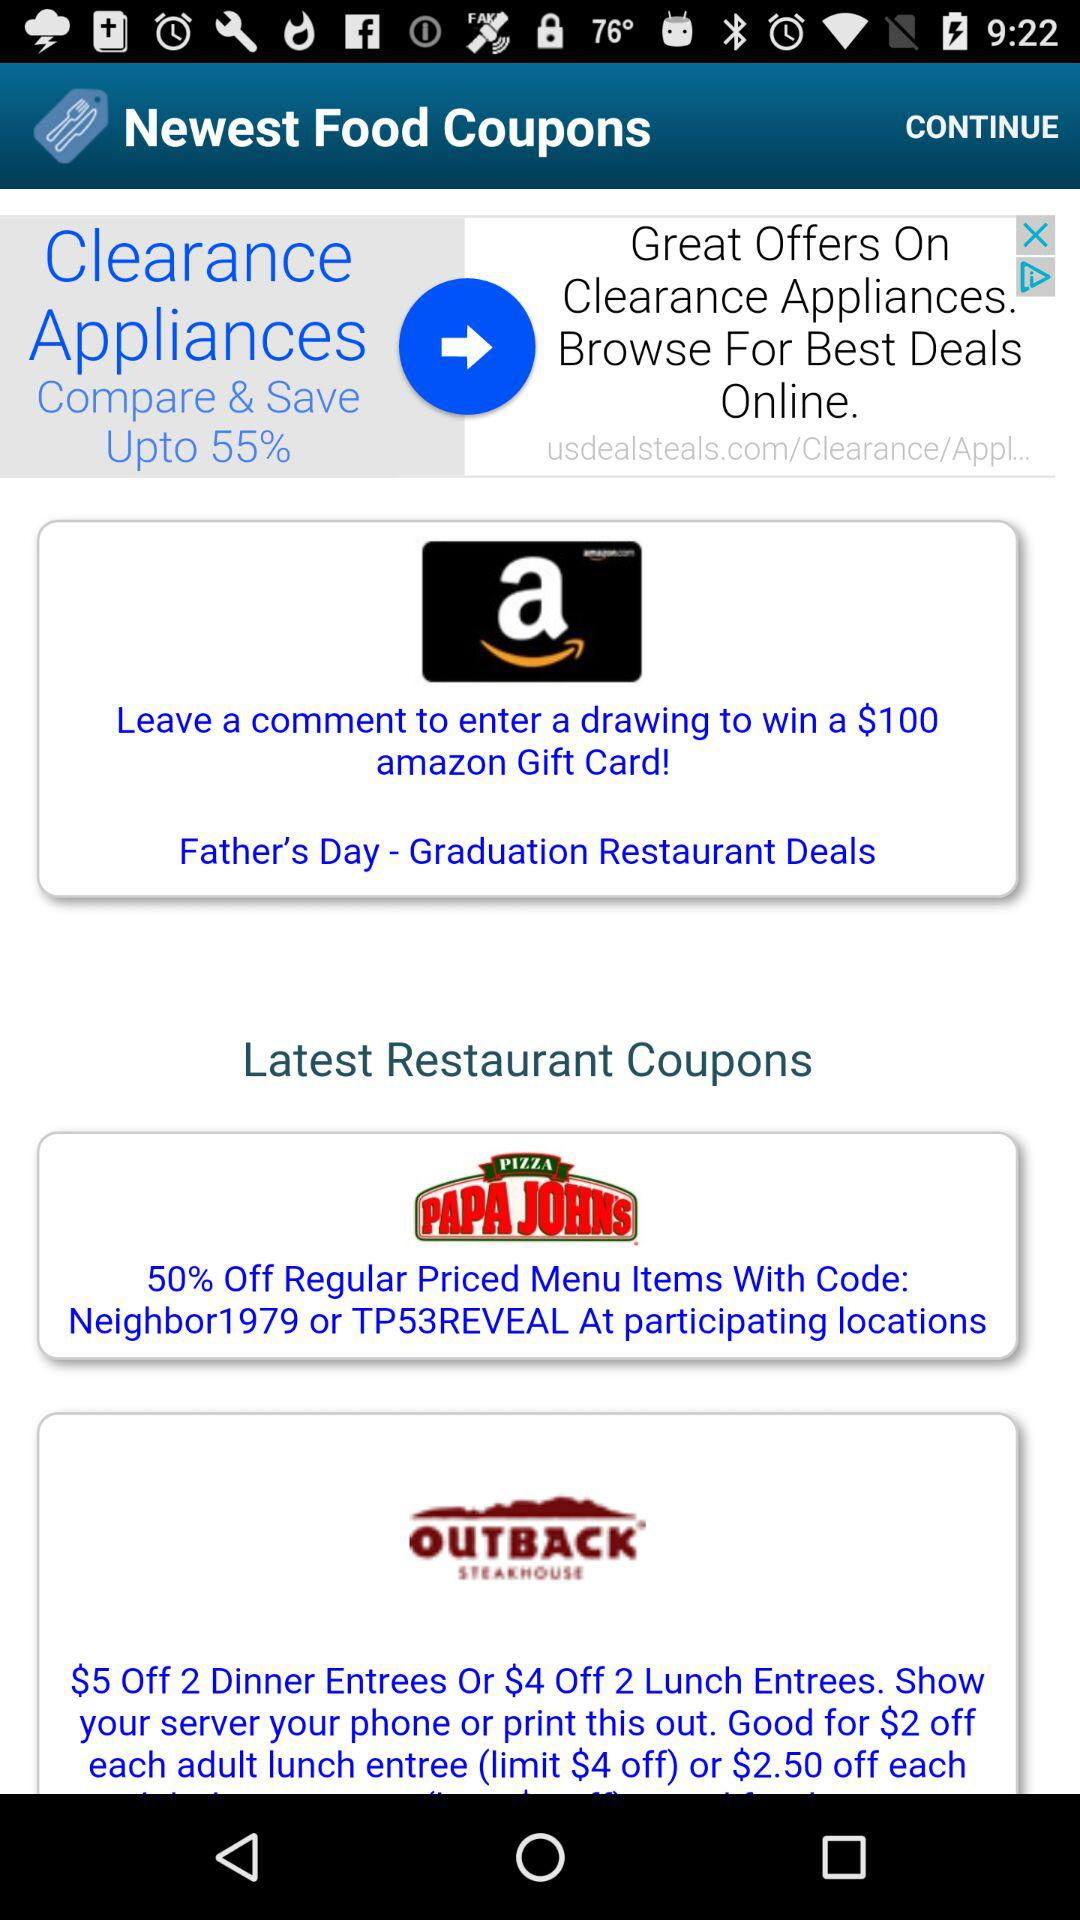How many more restaurant coupons are there than appliance coupons?
Answer the question using a single word or phrase. 2 